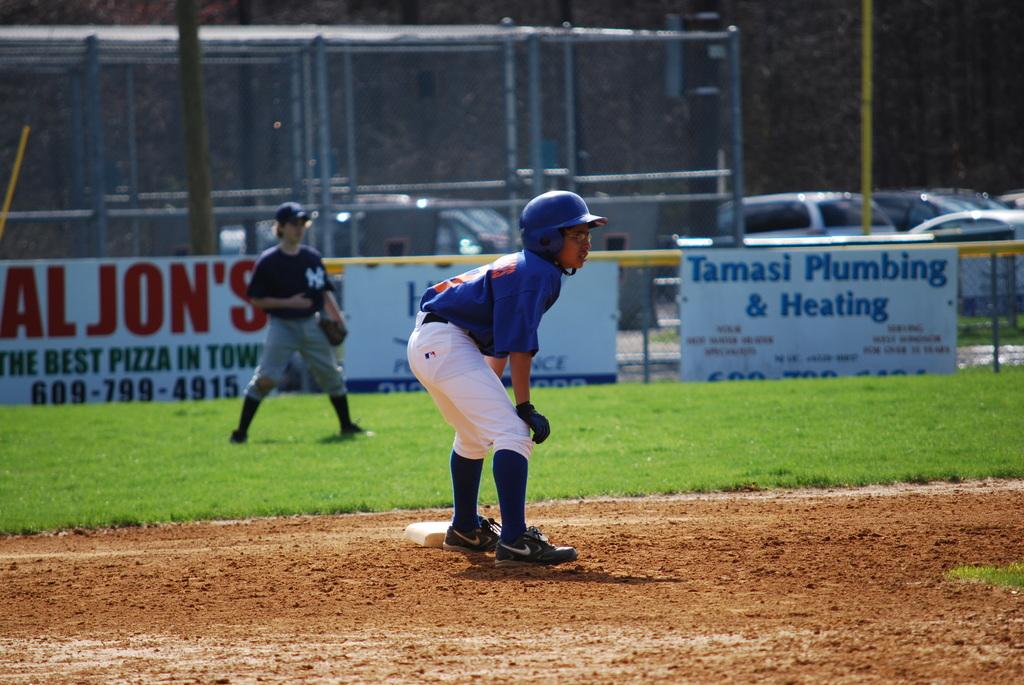Is aljoh's really the best pizza in town?
Your answer should be very brief. Yes. What's the name of the plumbing company on the poster?
Provide a succinct answer. Tamasi plumbing & heating. 